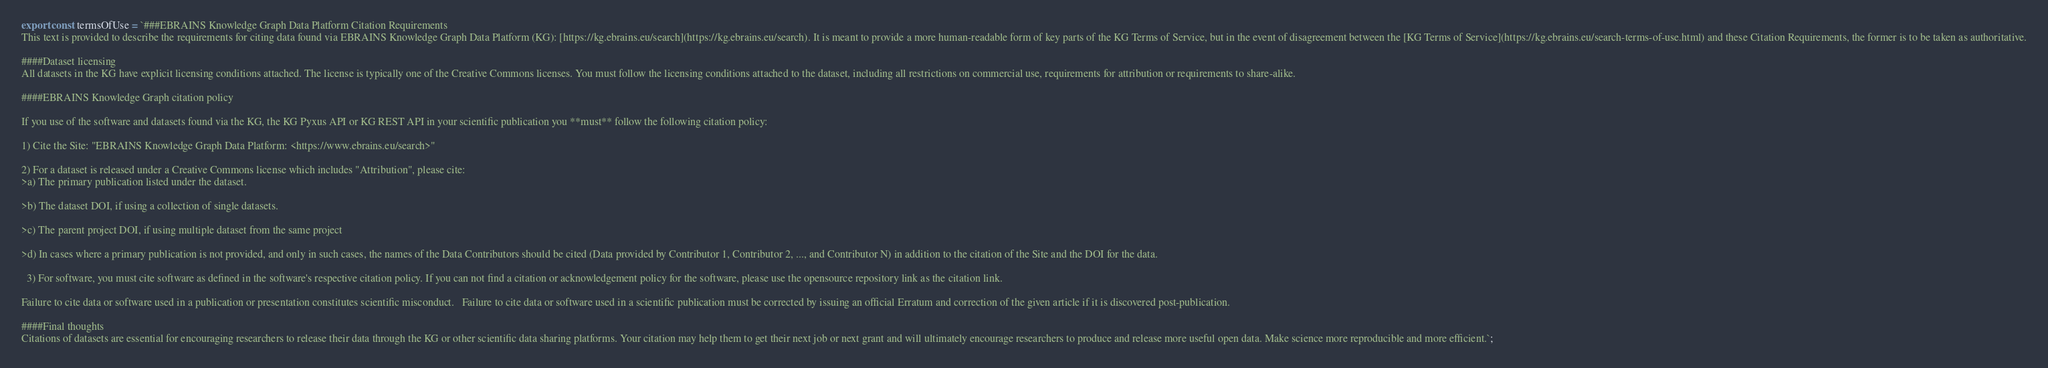Convert code to text. <code><loc_0><loc_0><loc_500><loc_500><_JavaScript_>export const termsOfUse = `###EBRAINS Knowledge Graph Data Platform Citation Requirements
This text is provided to describe the requirements for citing data found via EBRAINS Knowledge Graph Data Platform (KG): [https://kg.ebrains.eu/search](https://kg.ebrains.eu/search). It is meant to provide a more human-readable form of key parts of the KG Terms of Service, but in the event of disagreement between the [KG Terms of Service](https://kg.ebrains.eu/search-terms-of-use.html) and these Citation Requirements, the former is to be taken as authoritative.

####Dataset licensing
All datasets in the KG have explicit licensing conditions attached. The license is typically one of the Creative Commons licenses. You must follow the licensing conditions attached to the dataset, including all restrictions on commercial use, requirements for attribution or requirements to share-alike.

####EBRAINS Knowledge Graph citation policy

If you use of the software and datasets found via the KG, the KG Pyxus API or KG REST API in your scientific publication you **must** follow the following citation policy:

1) Cite the Site: "EBRAINS Knowledge Graph Data Platform: <https://www.ebrains.eu/search>"

2) For a dataset is released under a Creative Commons license which includes "Attribution", please cite:   
>a) The primary publication listed under the dataset.

>b) The dataset DOI, if using a collection of single datasets.

>c) The parent project DOI, if using multiple dataset from the same project

>d) In cases where a primary publication is not provided, and only in such cases, the names of the Data Contributors should be cited (Data provided by Contributor 1, Contributor 2, ..., and Contributor N) in addition to the citation of the Site and the DOI for the data.

  3) For software, you must cite software as defined in the software's respective citation policy. If you can not find a citation or acknowledgement policy for the software, please use the opensource repository link as the citation link.

Failure to cite data or software used in a publication or presentation constitutes scientific misconduct.   Failure to cite data or software used in a scientific publication must be corrected by issuing an official Erratum and correction of the given article if it is discovered post-publication.

####Final thoughts
Citations of datasets are essential for encouraging researchers to release their data through the KG or other scientific data sharing platforms. Your citation may help them to get their next job or next grant and will ultimately encourage researchers to produce and release more useful open data. Make science more reproducible and more efficient.`;
</code> 